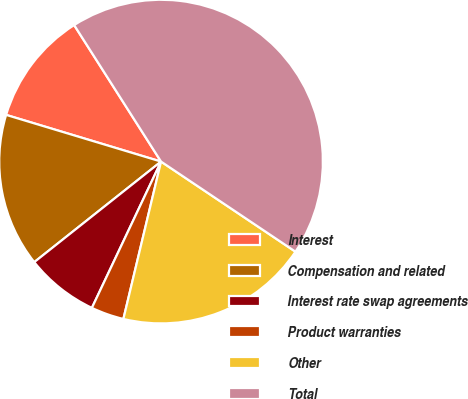<chart> <loc_0><loc_0><loc_500><loc_500><pie_chart><fcel>Interest<fcel>Compensation and related<fcel>Interest rate swap agreements<fcel>Product warranties<fcel>Other<fcel>Total<nl><fcel>11.32%<fcel>15.33%<fcel>7.3%<fcel>3.29%<fcel>19.34%<fcel>43.42%<nl></chart> 